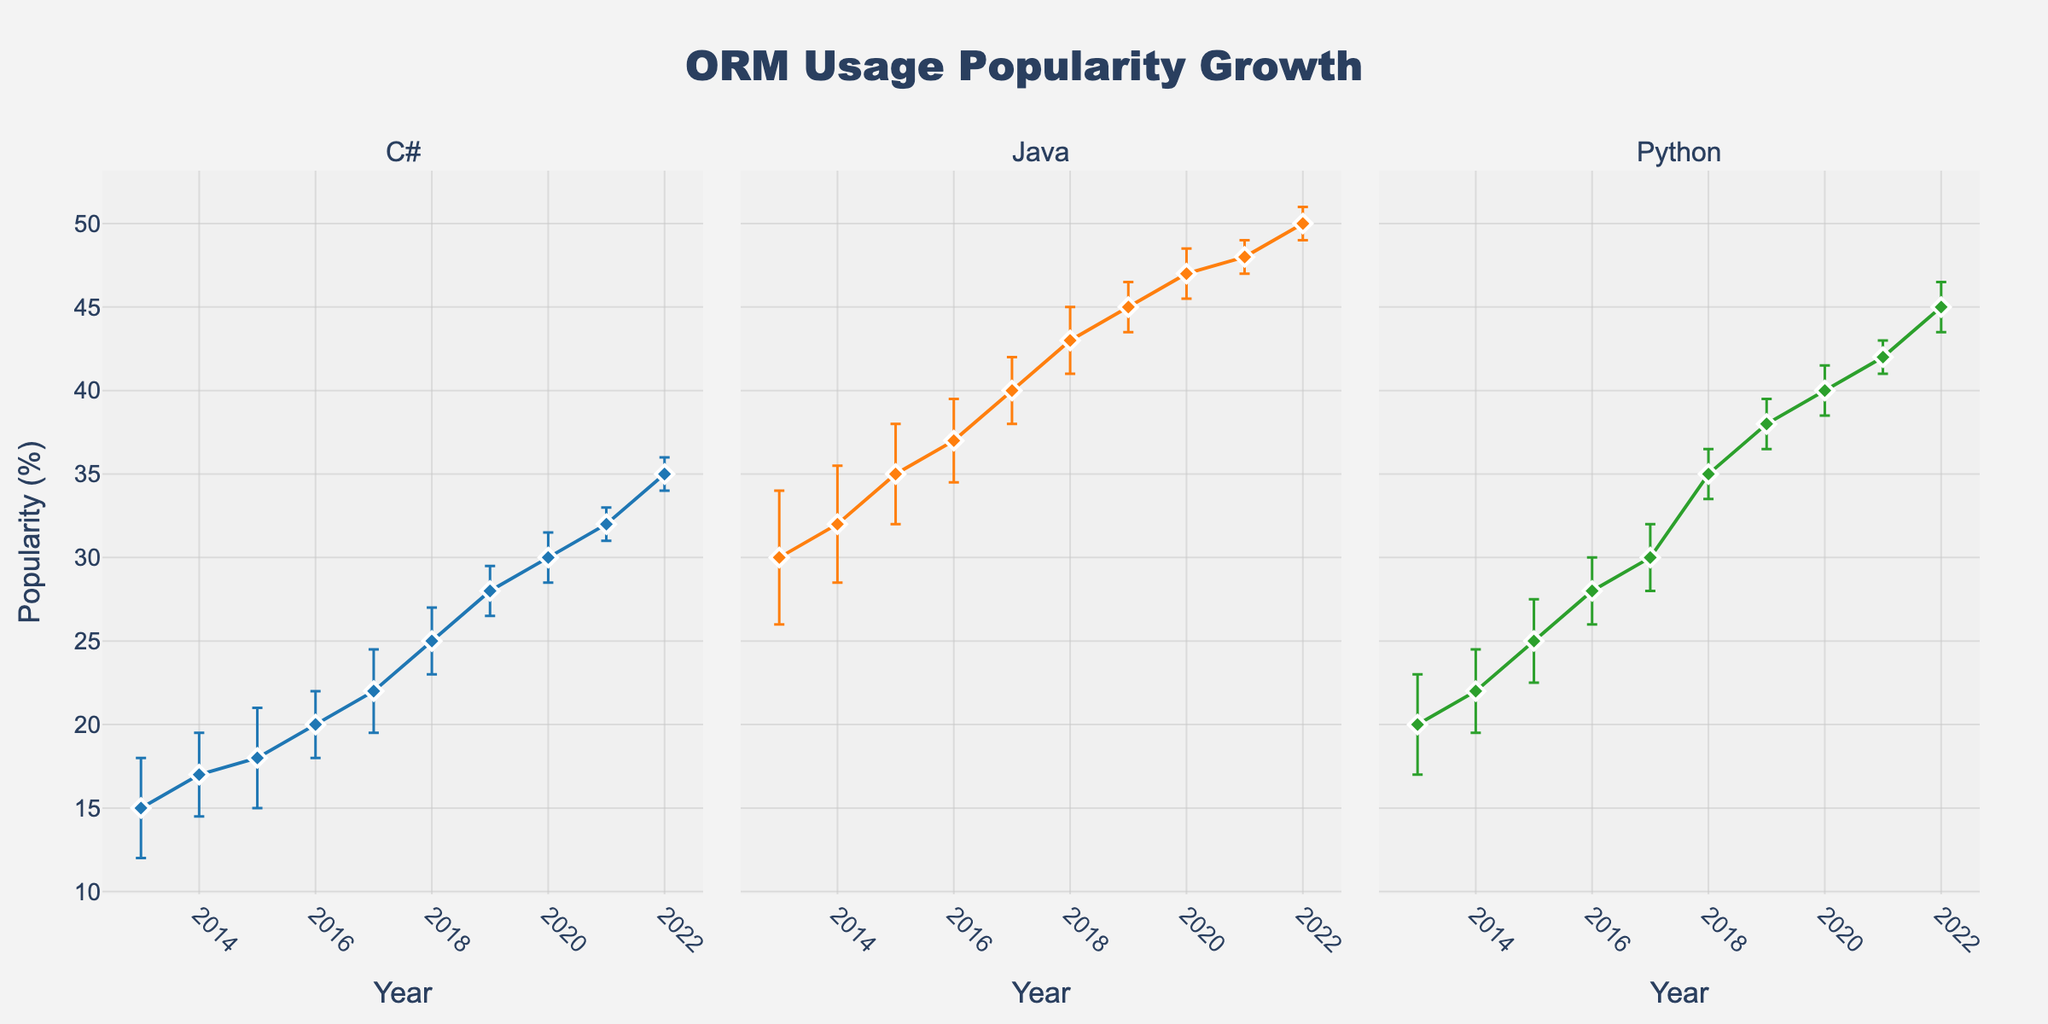What is the title of the figure? The title of the figure is located at the top center and is usually in a larger font size. By reading this text, we can find out what the chart is about.
Answer: ORM Usage Popularity Growth What programming languages are represented in the figure? The programming languages are indicated in the subplot titles at the top of each subplot. By looking at these titles, we can see the names of the programming languages.
Answer: C#, Java, Python What does the y-axis represent? The y-axis is common to all subplots and its label is visible on the leftmost side of the figure. By reading this label, we can determine what the y-axis represents.
Answer: Popularity (%) In which year does C# show the highest popularity growth, and what is the value? To find the year with the highest popularity, we look for the data point at the highest y-value in the C# subplot. The x-coordinate of this point will give us the year, and the y-coordinate gives the value.
Answer: 2022, 35% Which programming language had the highest popularity percentage in 2019 and what was it? By comparing the y-values at the x-coordinate corresponding to 2019 in each subplot, we can determine which language had the highest popularity.
Answer: Java, 45% What's the difference in popularity between Java and Python in 2013? We look at the y-values for Java and Python at the x-coordinate for 2013. Subtract the y-value of Python from that of Java to get the difference.
Answer: 10% (30% - 20%) How has the error margin changed for Python from 2013 to 2022? By observing the error bars (vertical lines) for Python from 2013 to 2022, we can see if they have become longer, shorter, or stayed the same.
Answer: The error margin has decreased Compare the slope of the lines for Java and C# between 2016 and 2017. Which one increased more rapidly? Calculating the slope involves seeing the change in y-value over the change in x-value (1 year). Compare the slopes for both languages for the given period.
Answer: Java increased more rapidly What is the average popularity of Python across the decade? Sum all the y-values for Python from 2013 to 2022 and divide by 10 to get the average.
Answer: (20+22+25+28+30+35+38+40+42+45)/10 = 32.5% Do all programming languages show continuous growth in popularity over the decade? By examining the direction of the line segments in each subplot from 2013 to 2022, we can determine if all languages show a continuous upward trend.
Answer: Yes 